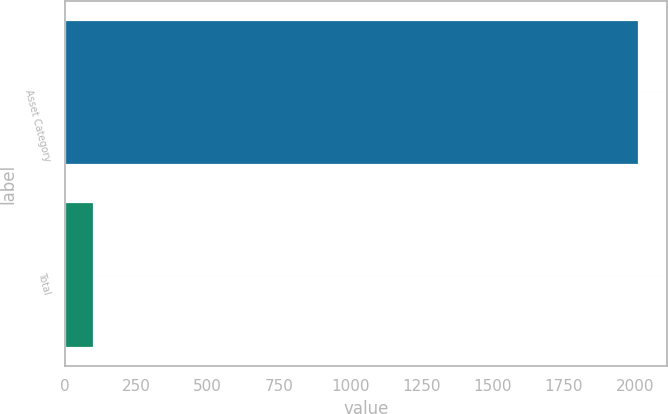Convert chart to OTSL. <chart><loc_0><loc_0><loc_500><loc_500><bar_chart><fcel>Asset Category<fcel>Total<nl><fcel>2012<fcel>100<nl></chart> 